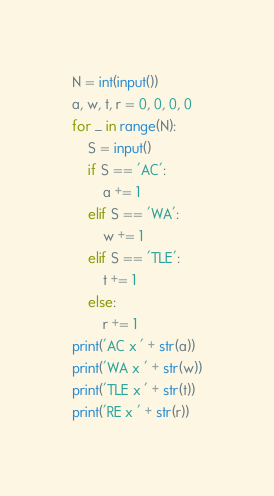<code> <loc_0><loc_0><loc_500><loc_500><_Python_>N = int(input())
a, w, t, r = 0, 0, 0, 0
for _ in range(N):
    S = input()
    if S == 'AC':
        a += 1
    elif S == 'WA':
        w += 1
    elif S == 'TLE':
        t += 1
    else:
        r += 1
print('AC x ' + str(a))
print('WA x ' + str(w))
print('TLE x ' + str(t))
print('RE x ' + str(r))</code> 